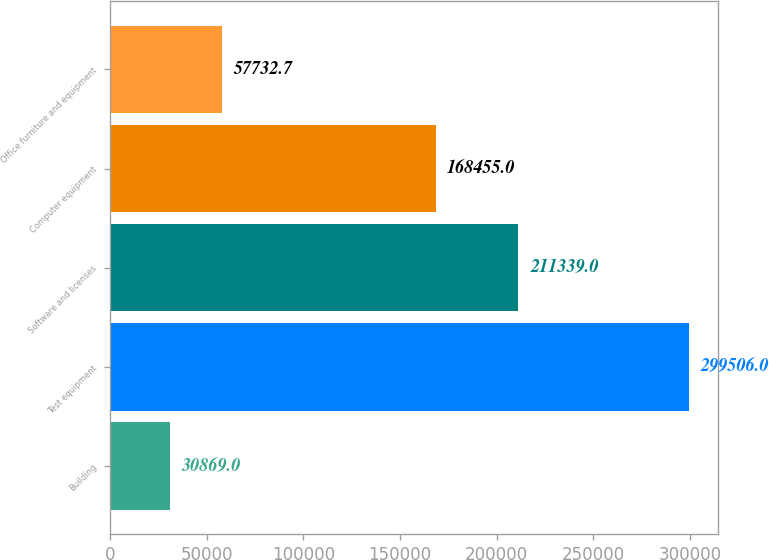<chart> <loc_0><loc_0><loc_500><loc_500><bar_chart><fcel>Building<fcel>Test equipment<fcel>Software and licenses<fcel>Computer equipment<fcel>Office furniture and equipment<nl><fcel>30869<fcel>299506<fcel>211339<fcel>168455<fcel>57732.7<nl></chart> 